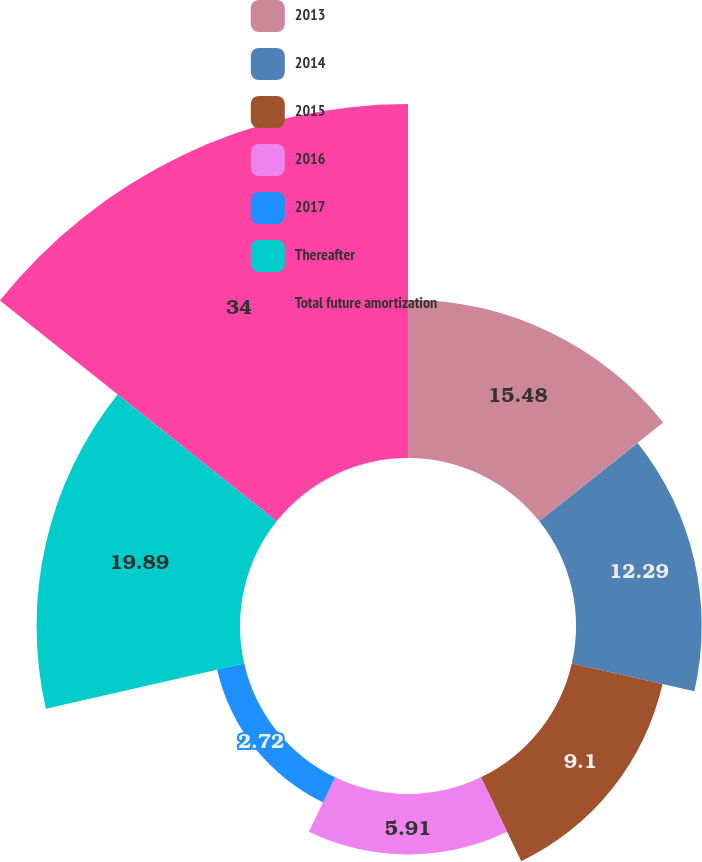<chart> <loc_0><loc_0><loc_500><loc_500><pie_chart><fcel>2013<fcel>2014<fcel>2015<fcel>2016<fcel>2017<fcel>Thereafter<fcel>Total future amortization<nl><fcel>15.48%<fcel>12.29%<fcel>9.1%<fcel>5.91%<fcel>2.72%<fcel>19.89%<fcel>34.61%<nl></chart> 